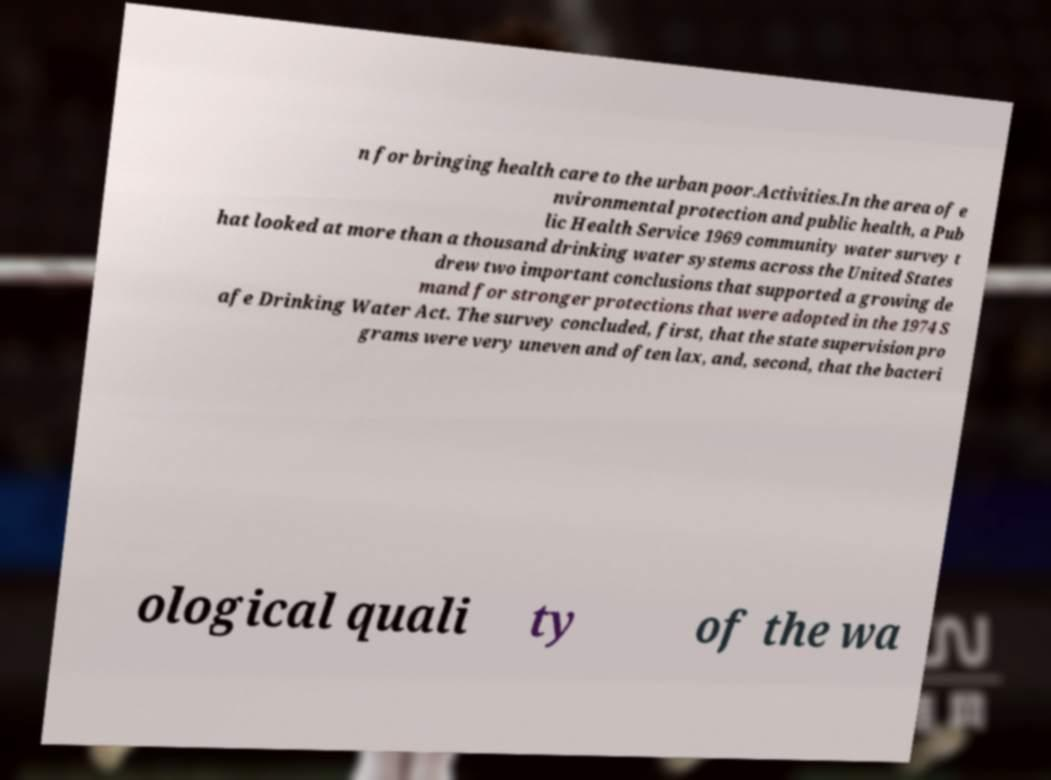Can you read and provide the text displayed in the image?This photo seems to have some interesting text. Can you extract and type it out for me? n for bringing health care to the urban poor.Activities.In the area of e nvironmental protection and public health, a Pub lic Health Service 1969 community water survey t hat looked at more than a thousand drinking water systems across the United States drew two important conclusions that supported a growing de mand for stronger protections that were adopted in the 1974 S afe Drinking Water Act. The survey concluded, first, that the state supervision pro grams were very uneven and often lax, and, second, that the bacteri ological quali ty of the wa 